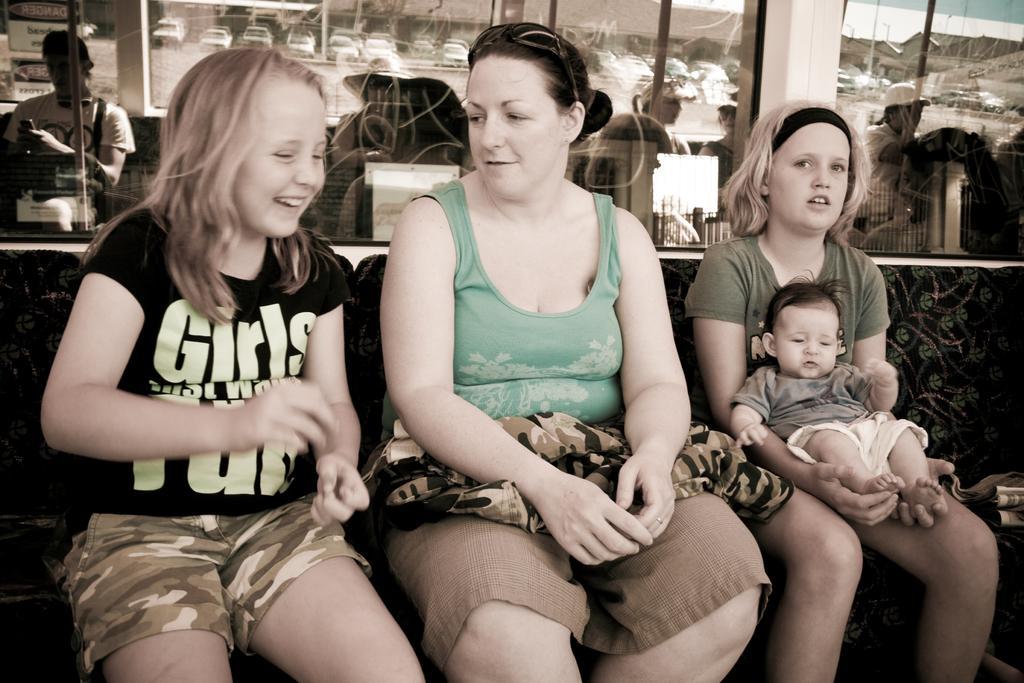Please provide a concise description of this image. In the center of the image three persons are sitting on a chair. In the background of the image we can see glass, wall, some cars are present. 